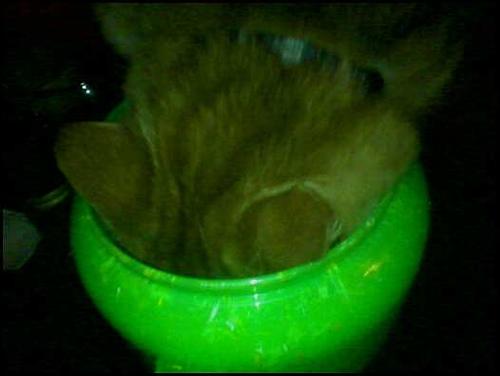How lit is the room?
Answer briefly. Dim. What color is the cat?
Be succinct. Orange. Why is the cat sticking it's face in a bowl?
Concise answer only. Drinking. 